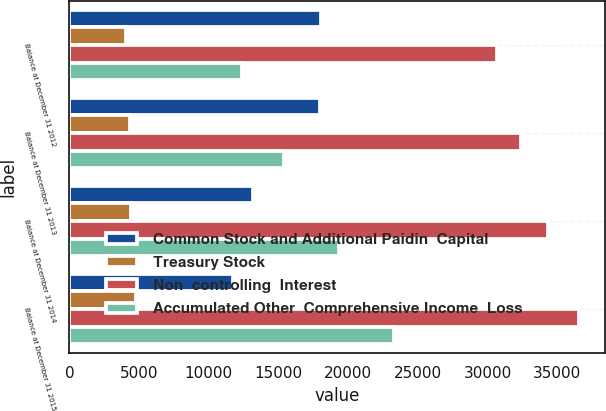<chart> <loc_0><loc_0><loc_500><loc_500><stacked_bar_chart><ecel><fcel>Balance at December 31 2012<fcel>Balance at December 31 2013<fcel>Balance at December 31 2014<fcel>Balance at December 31 2015<nl><fcel>Common Stock and Additional Paidin  Capital<fcel>18040<fcel>17948<fcel>13142<fcel>11747<nl><fcel>Treasury Stock<fcel>4053<fcel>4384<fcel>4388<fcel>4800<nl><fcel>Non  controlling  Interest<fcel>30679<fcel>32416<fcel>34317<fcel>36575<nl><fcel>Accumulated Other  Comprehensive Income  Loss<fcel>12407<fcel>15385<fcel>19307<fcel>23308<nl></chart> 